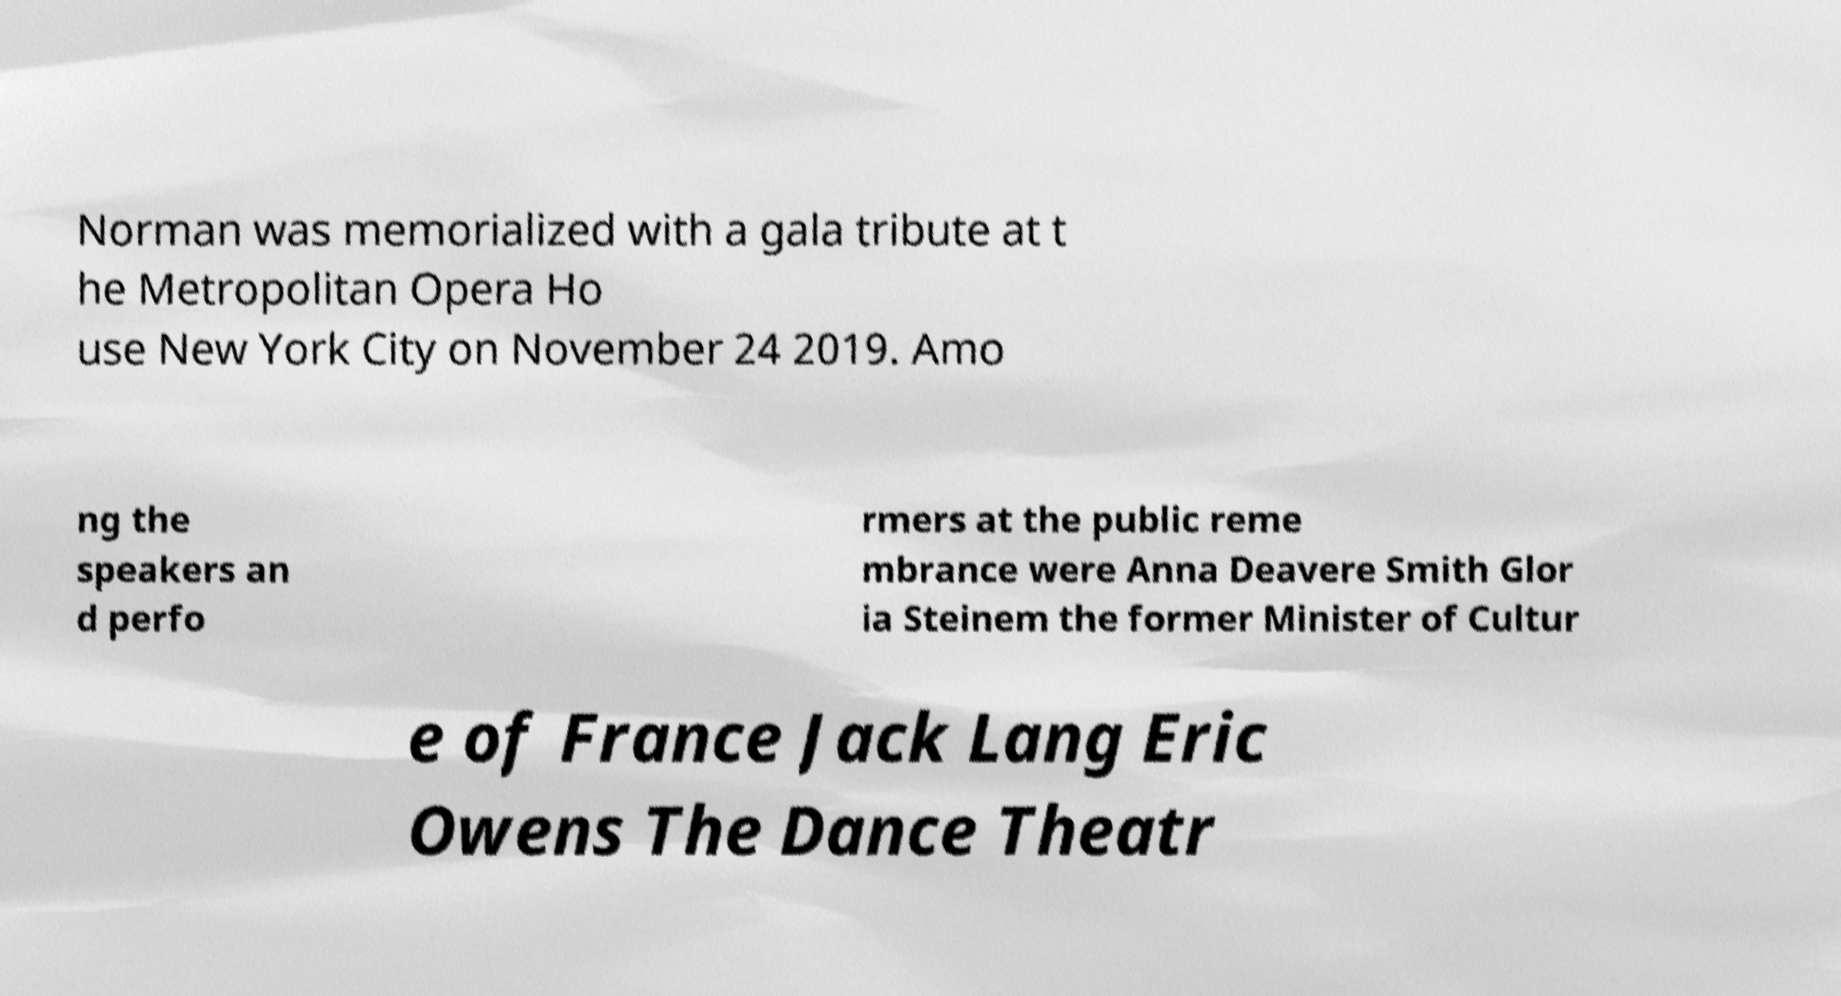Could you assist in decoding the text presented in this image and type it out clearly? Norman was memorialized with a gala tribute at t he Metropolitan Opera Ho use New York City on November 24 2019. Amo ng the speakers an d perfo rmers at the public reme mbrance were Anna Deavere Smith Glor ia Steinem the former Minister of Cultur e of France Jack Lang Eric Owens The Dance Theatr 